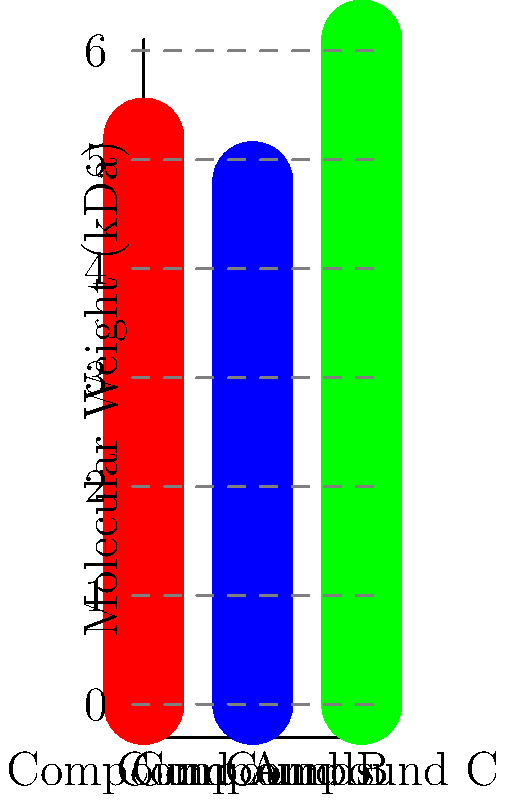Based on the molecular weight distribution of three plant-derived compounds shown in the graph, which compound would likely have the most complex structure and potentially offer the most diverse cosmetic applications? To answer this question, we need to analyze the molecular weights of the three compounds and understand their implications:

1. Compound A has a molecular weight of 5.2 kDa
2. Compound B has a molecular weight of 4.8 kDa
3. Compound C has a molecular weight of 6.1 kDa

In general, a higher molecular weight often correlates with:

a) More complex molecular structures
b) A greater number of functional groups
c) Increased potential for diverse interactions with other molecules

Compound C has the highest molecular weight at 6.1 kDa, which suggests:

1. It likely has the most complex structure among the three compounds.
2. It may contain more functional groups, potentially offering a wider range of chemical interactions.
3. Its larger size could provide benefits such as improved film-forming properties or enhanced moisture retention in cosmetic formulations.

These characteristics typically translate to more diverse applications in cosmetics, such as:

- Enhanced moisturizing effects
- Improved texture in formulations
- Potential for multiple bioactive properties (e.g., antioxidant, anti-inflammatory)
- Better stability or controlled release of active ingredients

Therefore, Compound C, with its higher molecular weight, is likely to have the most complex structure and offer the most diverse cosmetic applications.
Answer: Compound C 